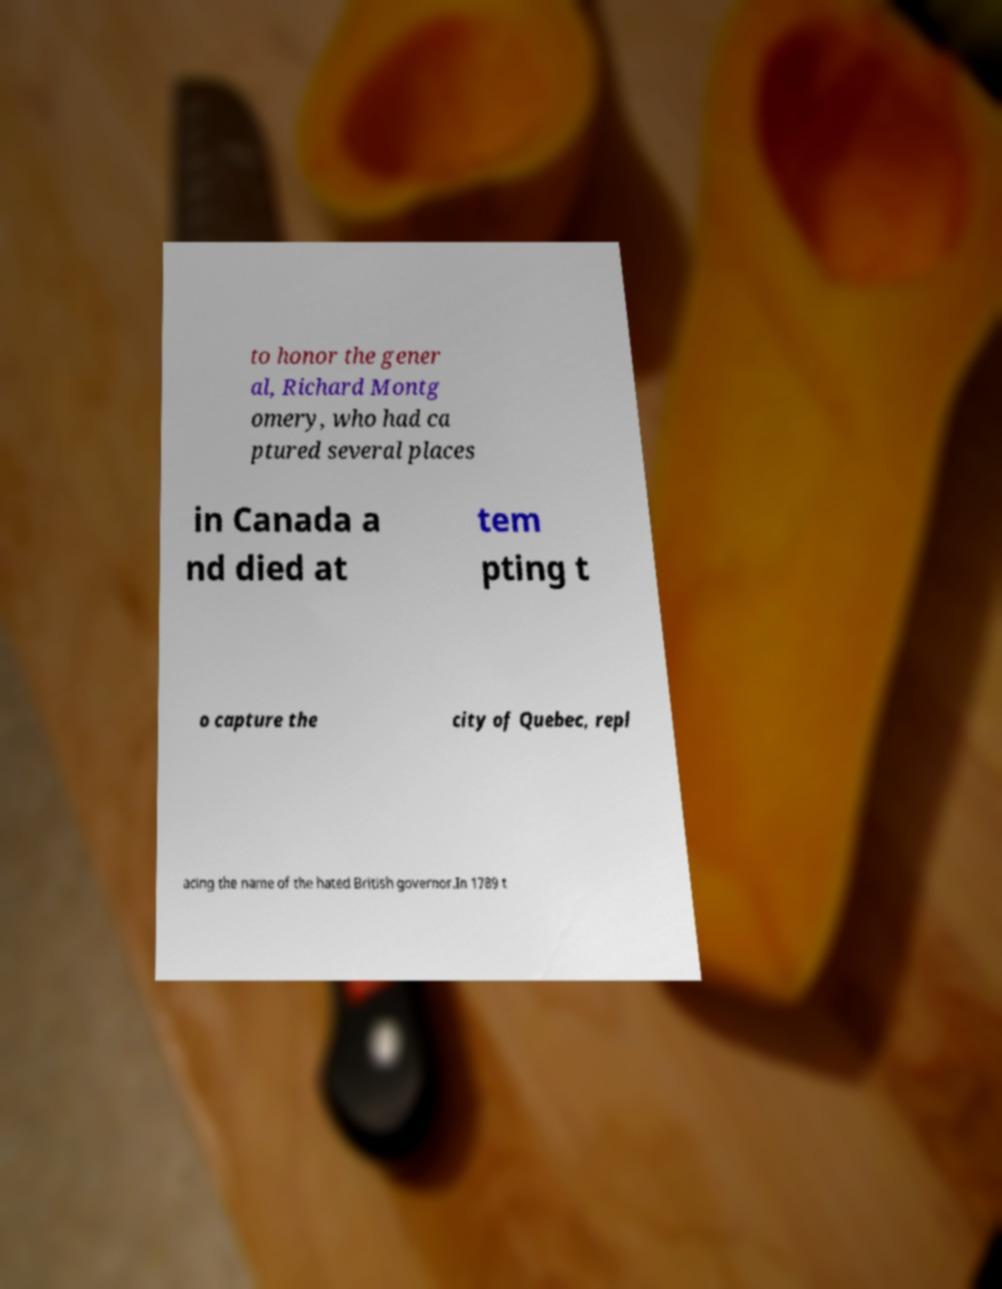Could you extract and type out the text from this image? to honor the gener al, Richard Montg omery, who had ca ptured several places in Canada a nd died at tem pting t o capture the city of Quebec, repl acing the name of the hated British governor.In 1789 t 